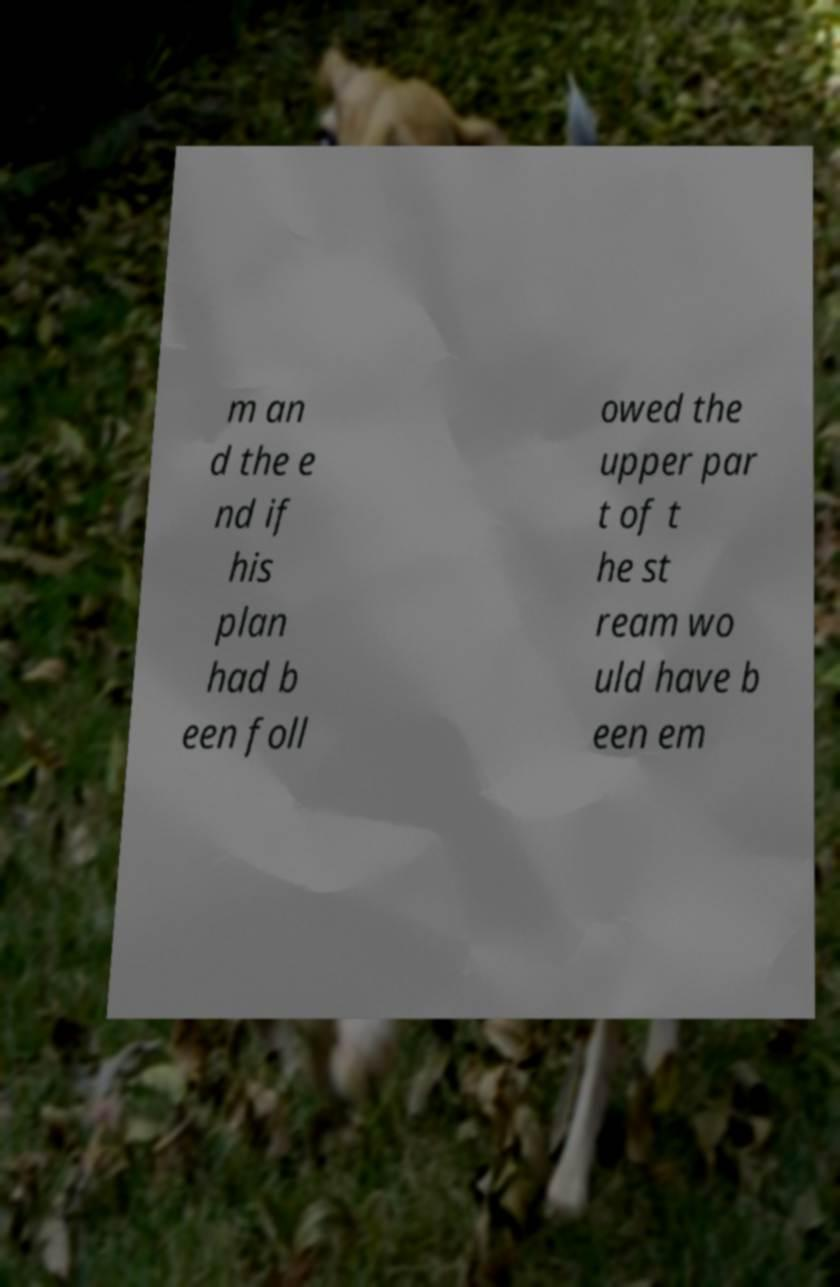Can you read and provide the text displayed in the image?This photo seems to have some interesting text. Can you extract and type it out for me? m an d the e nd if his plan had b een foll owed the upper par t of t he st ream wo uld have b een em 